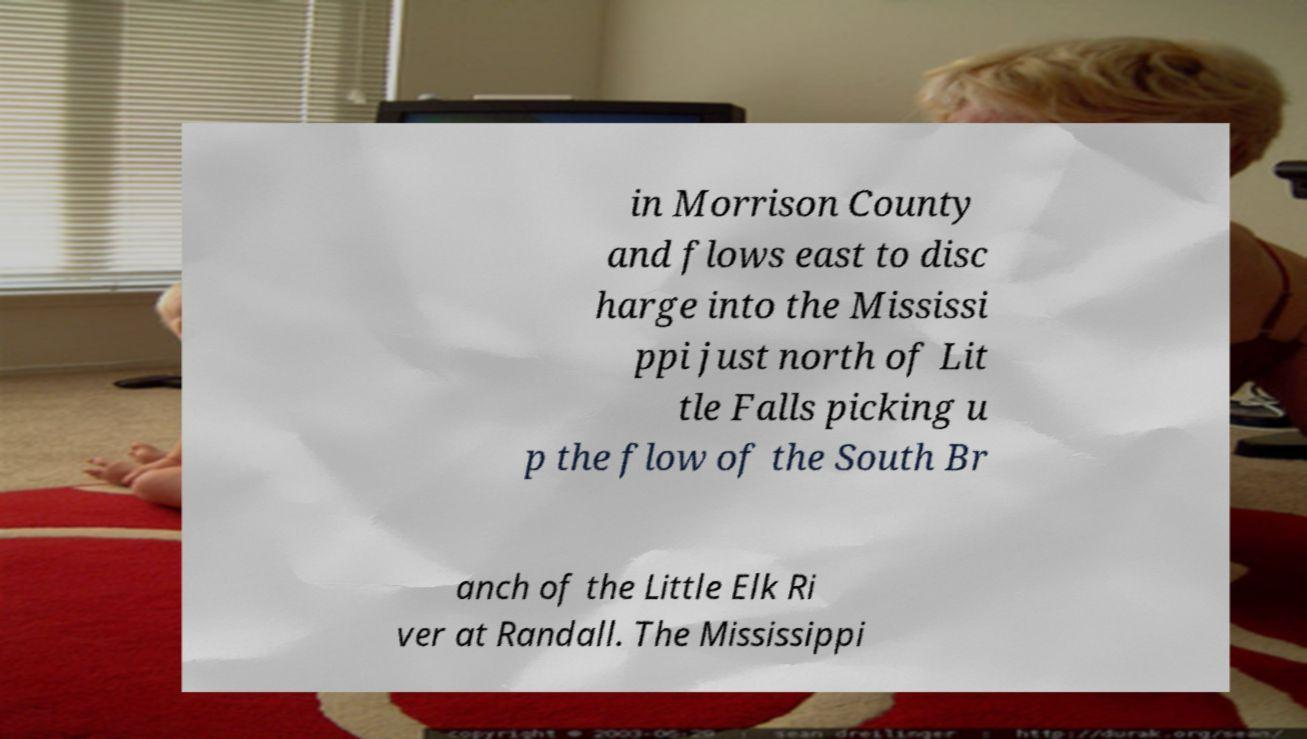What messages or text are displayed in this image? I need them in a readable, typed format. in Morrison County and flows east to disc harge into the Mississi ppi just north of Lit tle Falls picking u p the flow of the South Br anch of the Little Elk Ri ver at Randall. The Mississippi 